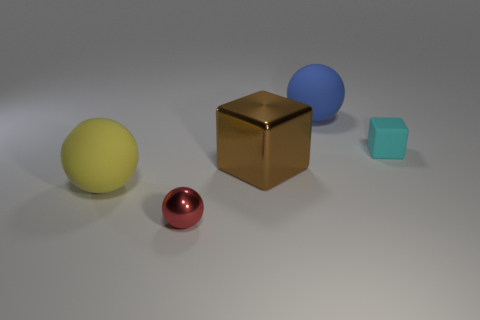How many tiny balls are made of the same material as the small cyan block?
Make the answer very short. 0. Is the size of the brown metallic object the same as the metallic object left of the big brown object?
Provide a short and direct response. No. What is the size of the rubber thing that is on the right side of the large matte ball behind the matte sphere that is to the left of the big brown cube?
Your response must be concise. Small. Are there more small cubes that are behind the yellow thing than tiny shiny objects that are to the right of the blue ball?
Provide a short and direct response. Yes. What number of tiny red metal objects are in front of the large matte thing on the left side of the small red metallic ball?
Keep it short and to the point. 1. Do the metallic sphere and the blue sphere have the same size?
Your response must be concise. No. What is the material of the small thing that is on the left side of the large object behind the big brown metallic block?
Your answer should be very brief. Metal. What is the material of the large yellow thing that is the same shape as the blue object?
Your answer should be compact. Rubber. There is a matte ball on the right side of the red metal object; is its size the same as the large block?
Your response must be concise. Yes. How many rubber things are either yellow things or large blue objects?
Provide a short and direct response. 2. 